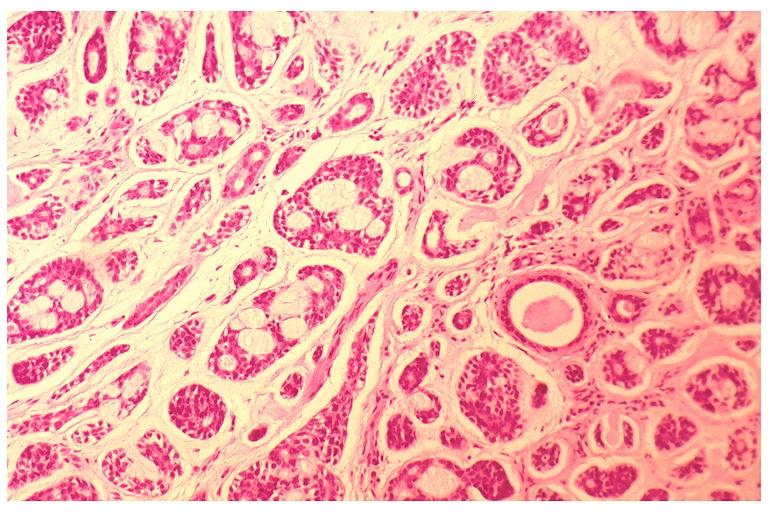what does this image show?
Answer the question using a single word or phrase. Adenoid cystic carcinoma 